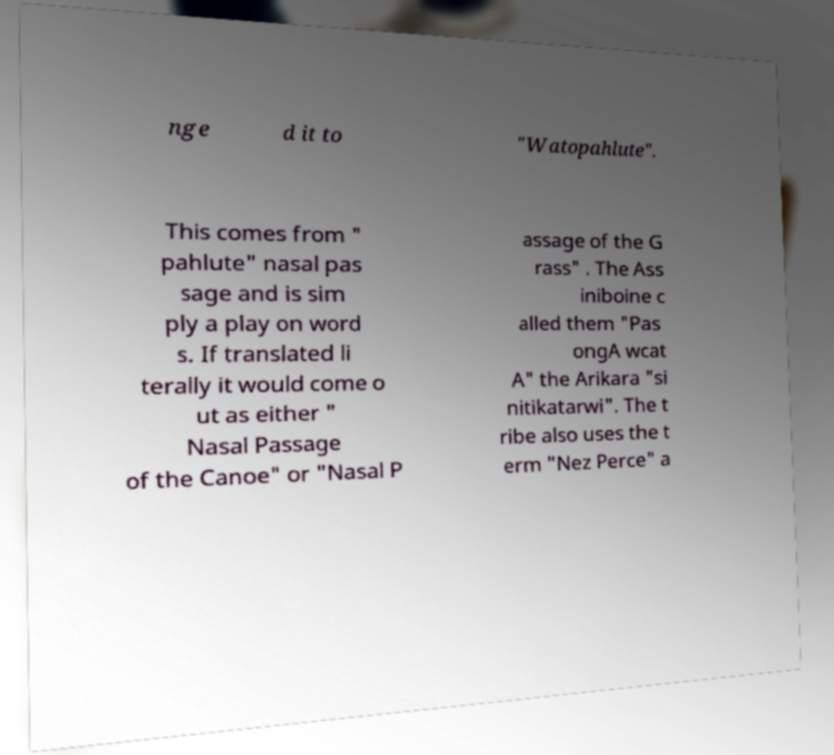Please read and relay the text visible in this image. What does it say? nge d it to "Watopahlute". This comes from " pahlute" nasal pas sage and is sim ply a play on word s. If translated li terally it would come o ut as either " Nasal Passage of the Canoe" or "Nasal P assage of the G rass" . The Ass iniboine c alled them "Pas ongA wcat A" the Arikara "si nitikatarwi". The t ribe also uses the t erm "Nez Perce" a 